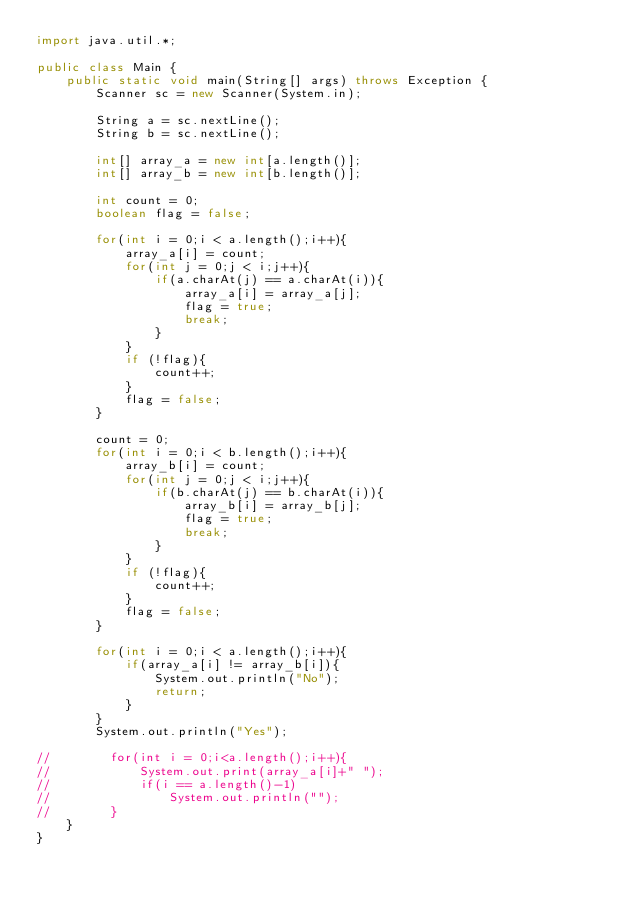Convert code to text. <code><loc_0><loc_0><loc_500><loc_500><_Java_>import java.util.*;

public class Main {
    public static void main(String[] args) throws Exception {
        Scanner sc = new Scanner(System.in);

        String a = sc.nextLine();
        String b = sc.nextLine();

        int[] array_a = new int[a.length()];
        int[] array_b = new int[b.length()];

        int count = 0;
        boolean flag = false;

        for(int i = 0;i < a.length();i++){
            array_a[i] = count;
            for(int j = 0;j < i;j++){
                if(a.charAt(j) == a.charAt(i)){
                    array_a[i] = array_a[j];
                    flag = true;
                    break;
                }
            }
            if (!flag){
                count++;
            }
            flag = false;
        }

        count = 0;
        for(int i = 0;i < b.length();i++){
            array_b[i] = count;
            for(int j = 0;j < i;j++){
                if(b.charAt(j) == b.charAt(i)){
                    array_b[i] = array_b[j];
                    flag = true;
                    break;
                }
            }
            if (!flag){
                count++;
            }
            flag = false;
        }

        for(int i = 0;i < a.length();i++){
            if(array_a[i] != array_b[i]){
                System.out.println("No");
                return;
            }
        }
        System.out.println("Yes");

//        for(int i = 0;i<a.length();i++){
//            System.out.print(array_a[i]+" ");
//            if(i == a.length()-1)
//                System.out.println("");
//        }
    }
}
</code> 